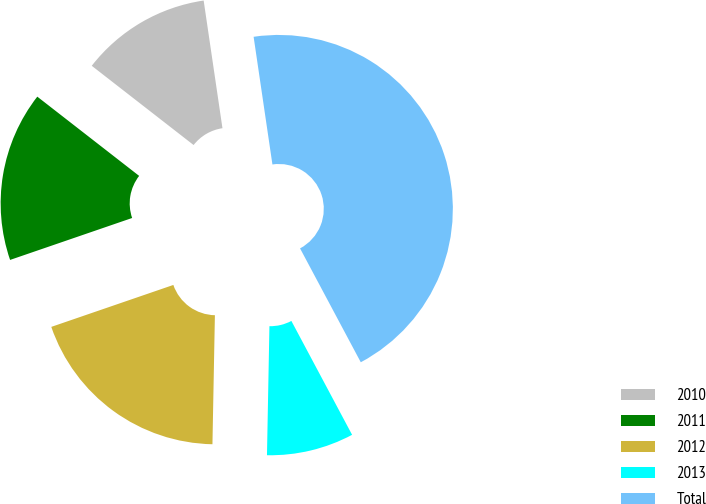Convert chart. <chart><loc_0><loc_0><loc_500><loc_500><pie_chart><fcel>2010<fcel>2011<fcel>2012<fcel>2013<fcel>Total<nl><fcel>12.15%<fcel>15.79%<fcel>19.43%<fcel>8.1%<fcel>44.53%<nl></chart> 